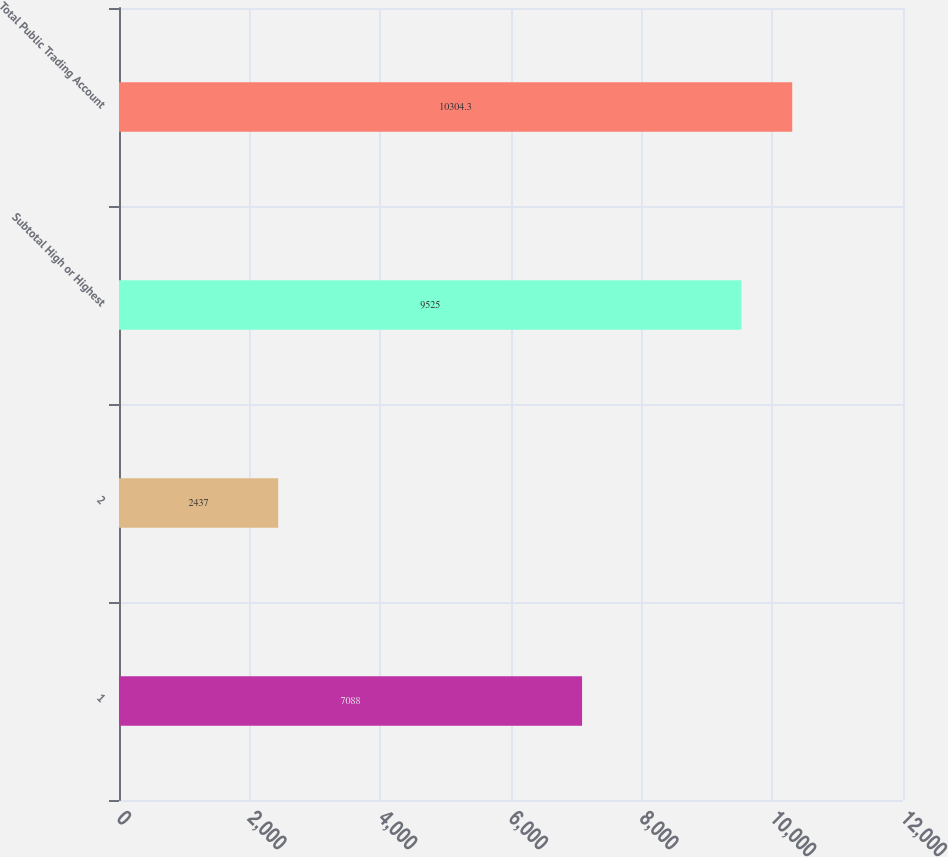Convert chart. <chart><loc_0><loc_0><loc_500><loc_500><bar_chart><fcel>1<fcel>2<fcel>Subtotal High or Highest<fcel>Total Public Trading Account<nl><fcel>7088<fcel>2437<fcel>9525<fcel>10304.3<nl></chart> 